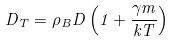Convert formula to latex. <formula><loc_0><loc_0><loc_500><loc_500>D _ { T } = \rho _ { B } D \left ( 1 + \frac { \gamma m } { k T } \right )</formula> 